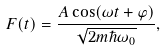Convert formula to latex. <formula><loc_0><loc_0><loc_500><loc_500>F ( t ) = \frac { A \cos ( \omega t + \varphi ) } { \sqrt { 2 m \hbar { \omega } _ { 0 } } } ,</formula> 